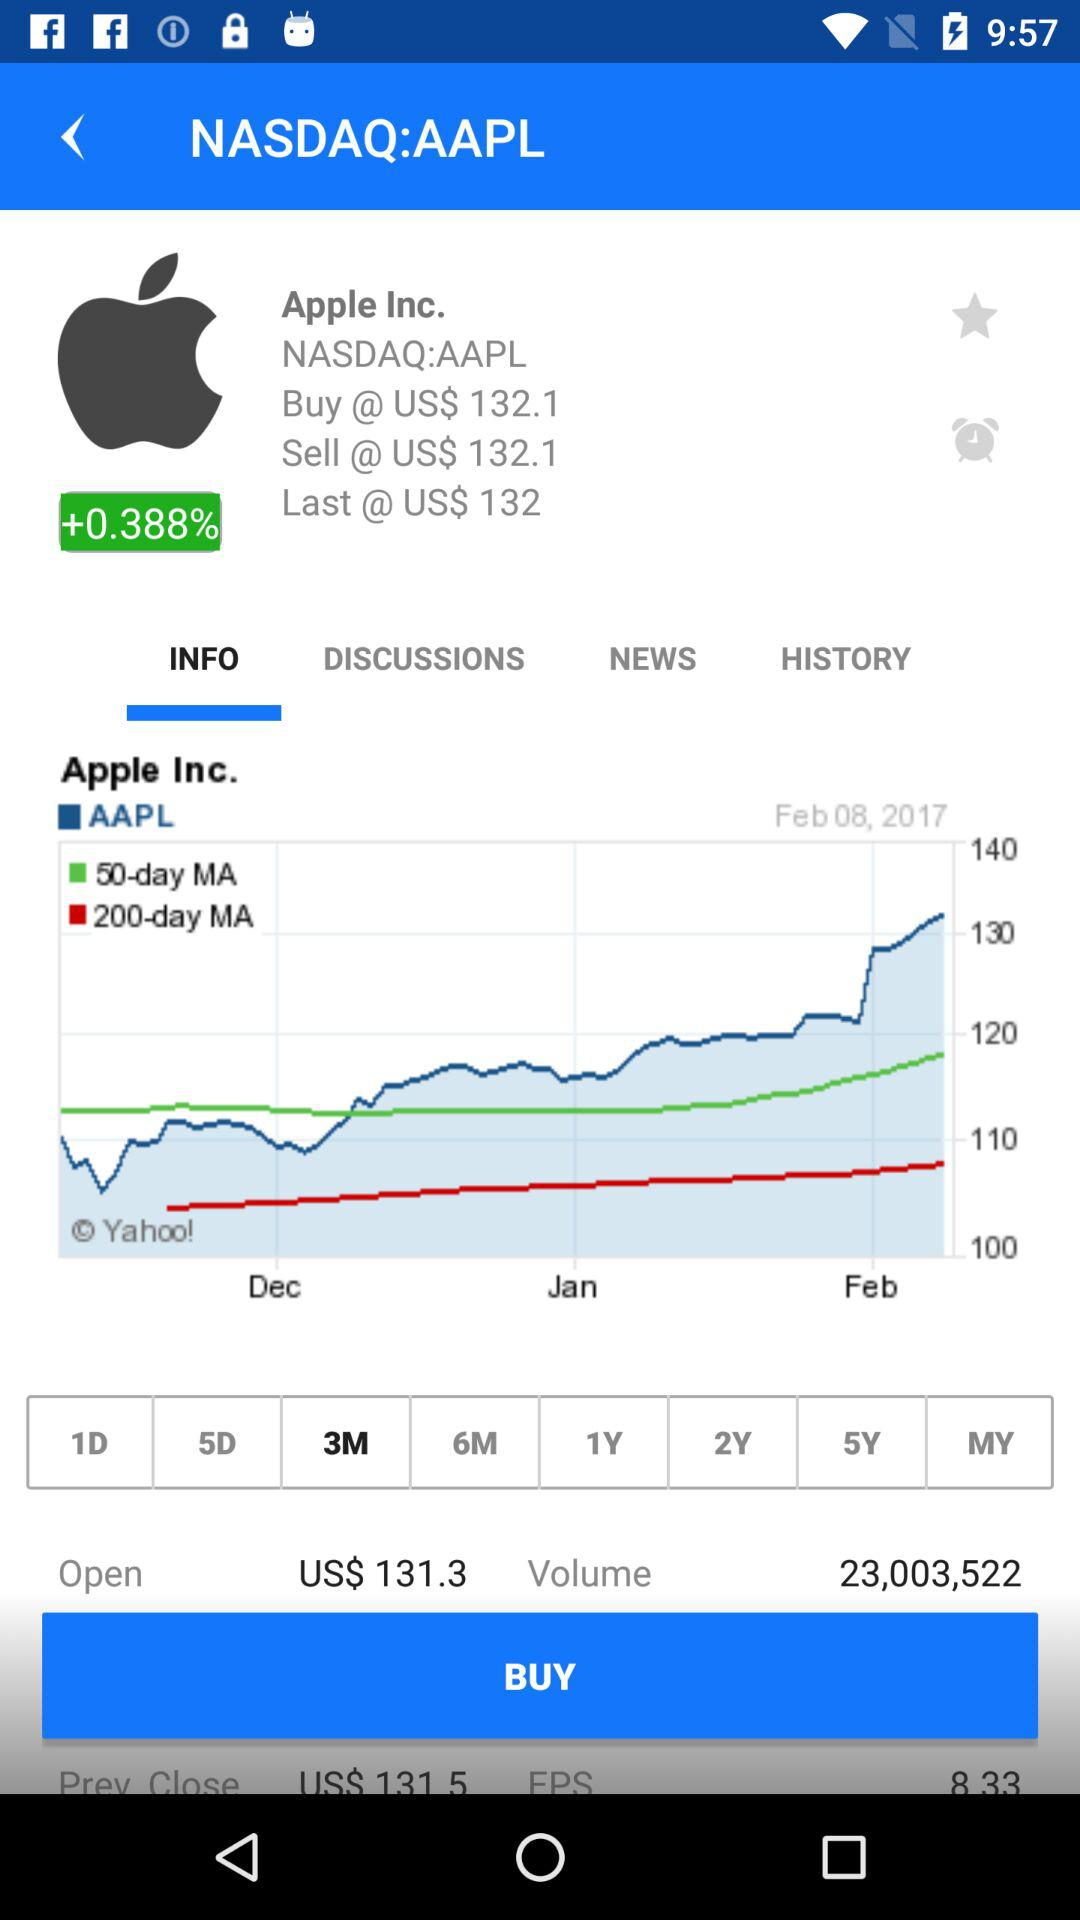What date is shown on the screen? The shown date is February 08, 2017. 